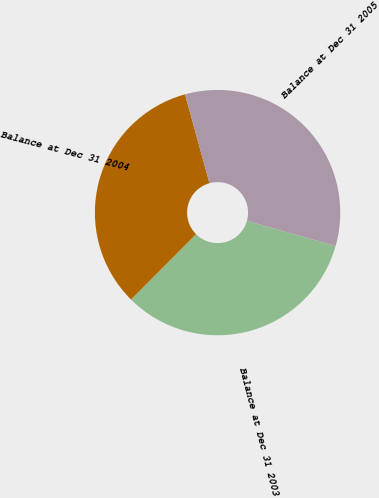<chart> <loc_0><loc_0><loc_500><loc_500><pie_chart><fcel>Balance at Dec 31 2003<fcel>Balance at Dec 31 2004<fcel>Balance at Dec 31 2005<nl><fcel>33.09%<fcel>33.26%<fcel>33.65%<nl></chart> 